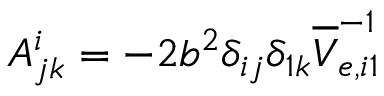<formula> <loc_0><loc_0><loc_500><loc_500>A _ { j k } ^ { i } = - 2 b ^ { 2 } \delta _ { i j } \delta _ { 1 k } \overline { V } _ { e , i 1 } ^ { - 1 }</formula> 